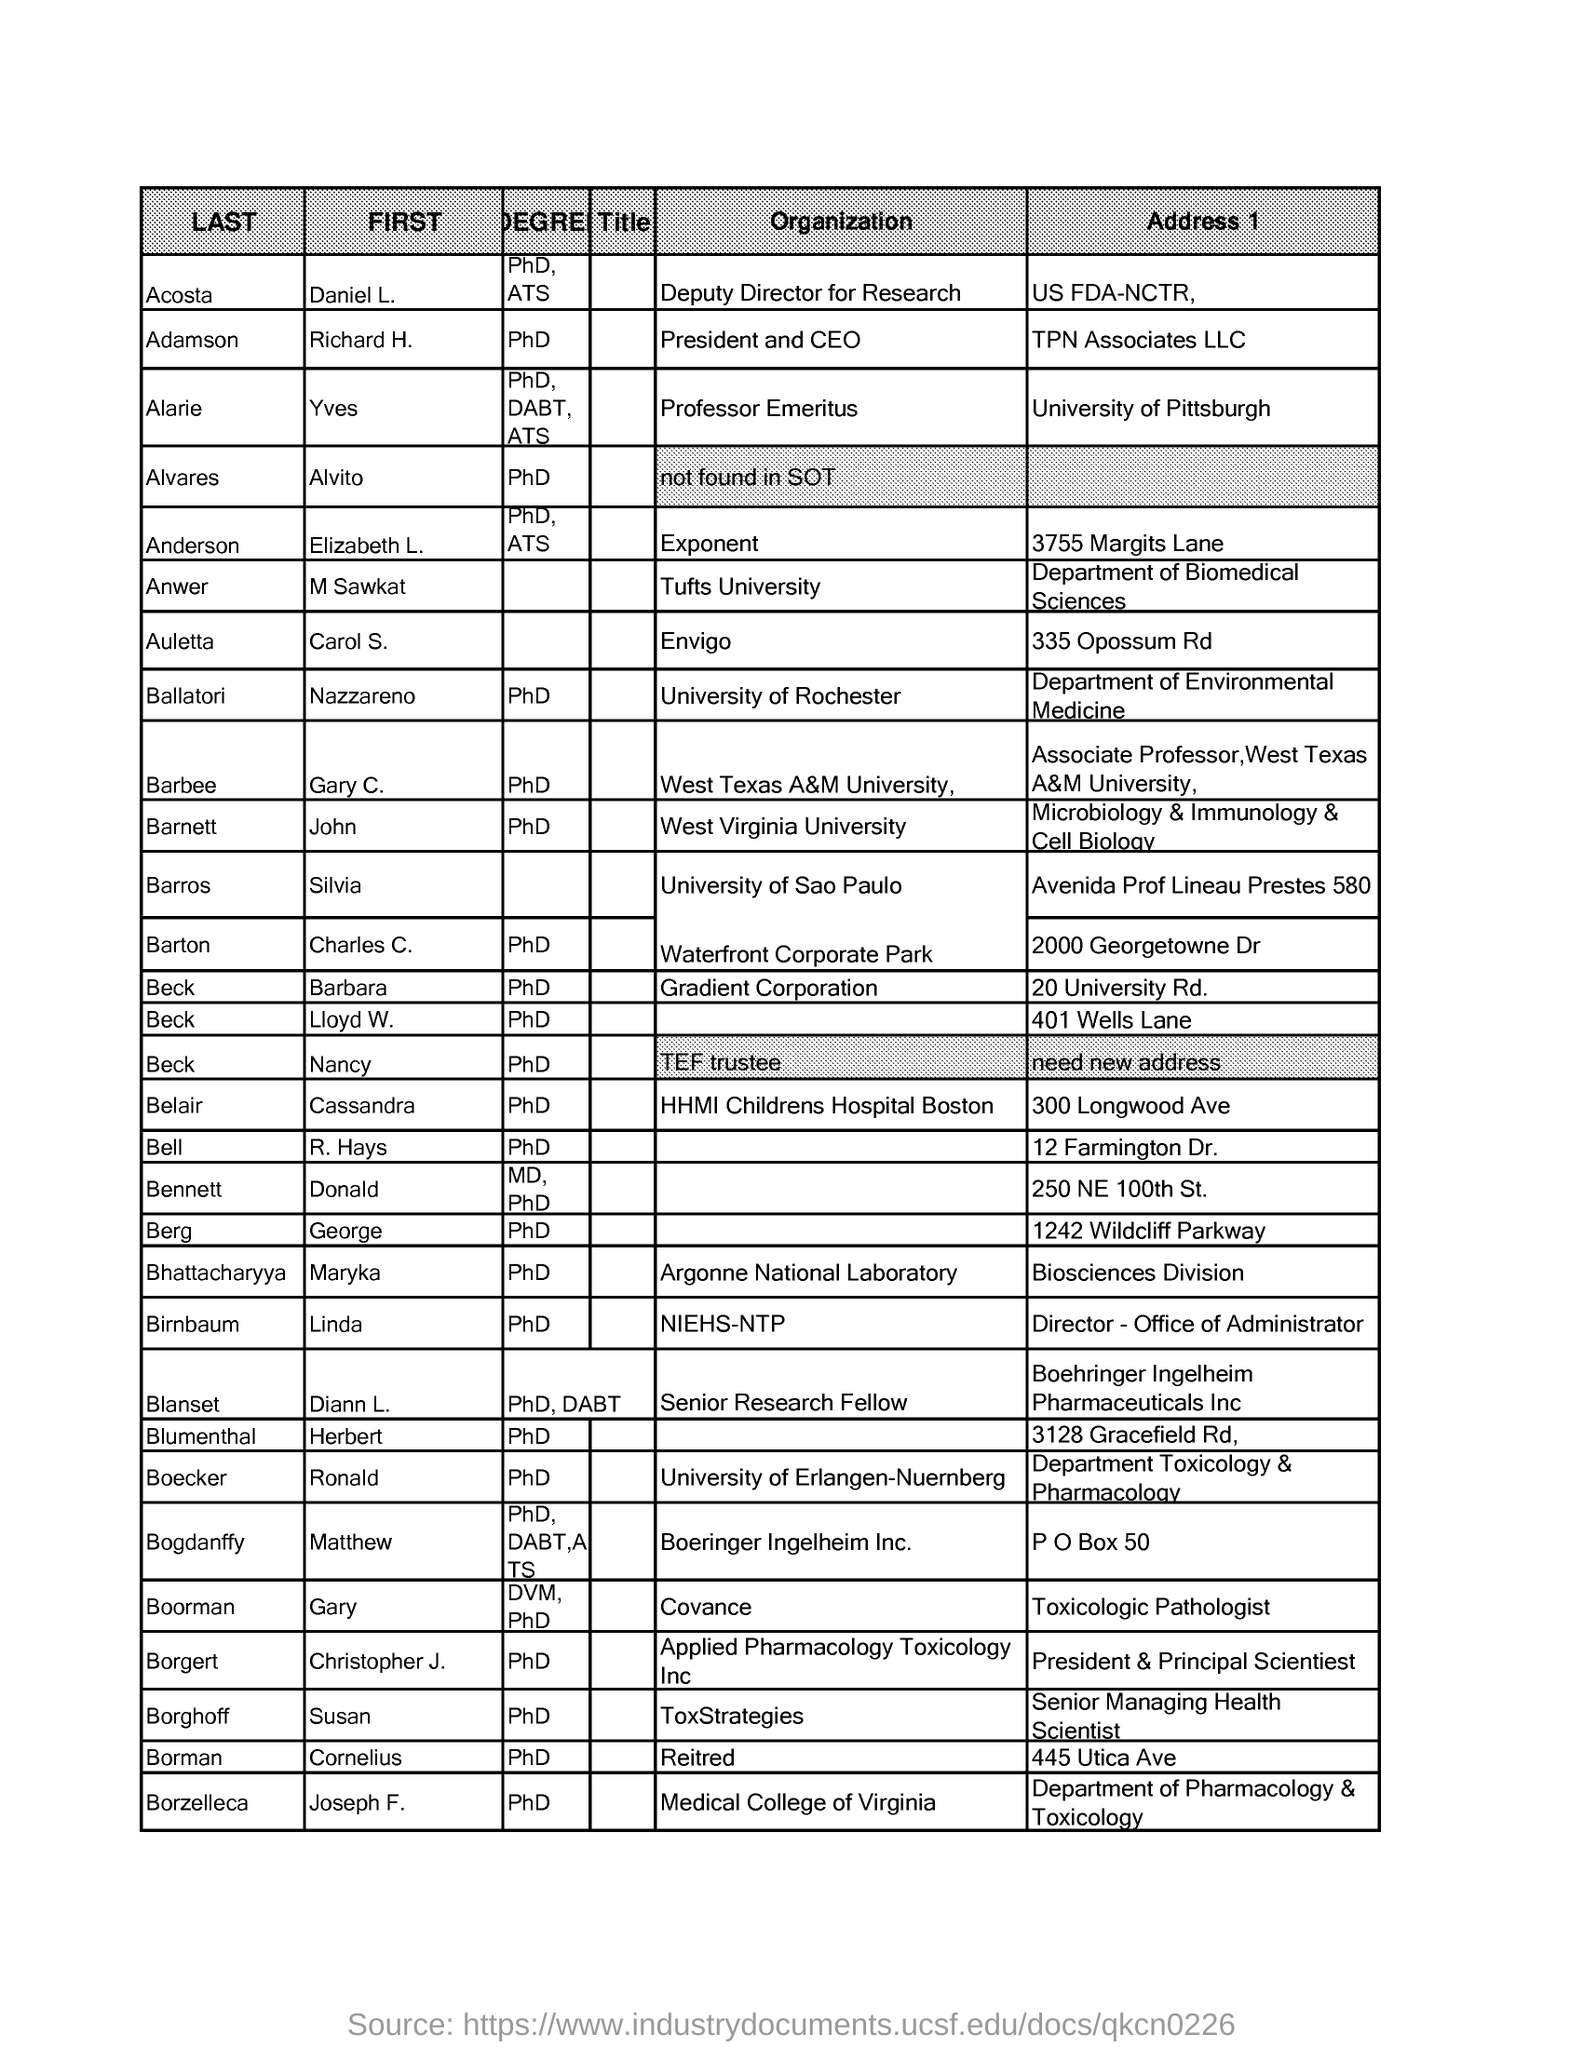What is the designation of Richard H. Adamson?
Your answer should be compact. President and CEO. What is the highest degree obtained by Charles C. Barton?
Your answer should be compact. PhD. What is the designation of Diann L. Blanset?
Keep it short and to the point. Senior Research Fellow. What is the address 1 of Daniel L. Acosta?
Your answer should be very brief. US FDA-NCTR,. In which university, M Sawkat Anwer works?
Provide a short and direct response. Tufts University. What is the highest degree obtained by Diann L. Blanset?
Provide a short and direct response. PhD, DABT. What is the designation of Daniel L. Acosta?
Offer a very short reply. Deputy Director for Research. What is the address 1 of Elizabeth L. Anderson?
Your answer should be compact. 3755 Margits Lane. 